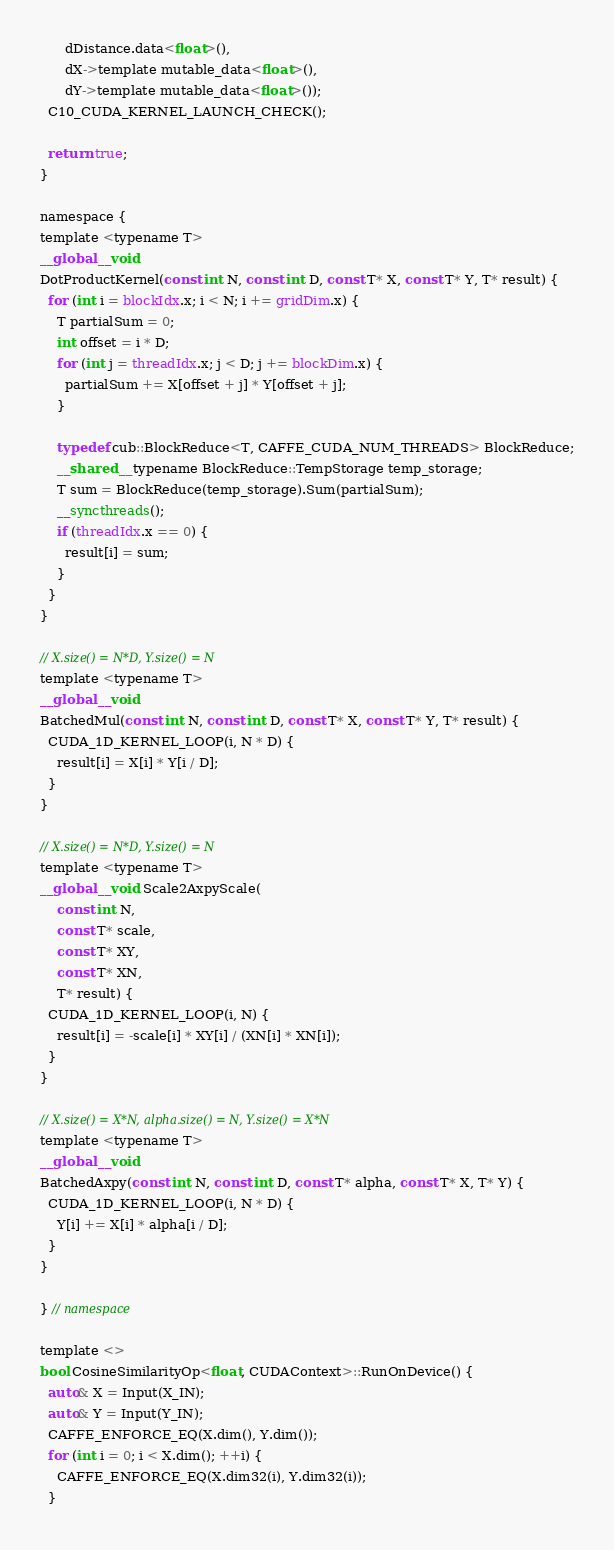<code> <loc_0><loc_0><loc_500><loc_500><_Cuda_>      dDistance.data<float>(),
      dX->template mutable_data<float>(),
      dY->template mutable_data<float>());
  C10_CUDA_KERNEL_LAUNCH_CHECK();

  return true;
}

namespace {
template <typename T>
__global__ void
DotProductKernel(const int N, const int D, const T* X, const T* Y, T* result) {
  for (int i = blockIdx.x; i < N; i += gridDim.x) {
    T partialSum = 0;
    int offset = i * D;
    for (int j = threadIdx.x; j < D; j += blockDim.x) {
      partialSum += X[offset + j] * Y[offset + j];
    }

    typedef cub::BlockReduce<T, CAFFE_CUDA_NUM_THREADS> BlockReduce;
    __shared__ typename BlockReduce::TempStorage temp_storage;
    T sum = BlockReduce(temp_storage).Sum(partialSum);
    __syncthreads();
    if (threadIdx.x == 0) {
      result[i] = sum;
    }
  }
}

// X.size() = N*D, Y.size() = N
template <typename T>
__global__ void
BatchedMul(const int N, const int D, const T* X, const T* Y, T* result) {
  CUDA_1D_KERNEL_LOOP(i, N * D) {
    result[i] = X[i] * Y[i / D];
  }
}

// X.size() = N*D, Y.size() = N
template <typename T>
__global__ void Scale2AxpyScale(
    const int N,
    const T* scale,
    const T* XY,
    const T* XN,
    T* result) {
  CUDA_1D_KERNEL_LOOP(i, N) {
    result[i] = -scale[i] * XY[i] / (XN[i] * XN[i]);
  }
}

// X.size() = X*N, alpha.size() = N, Y.size() = X*N
template <typename T>
__global__ void
BatchedAxpy(const int N, const int D, const T* alpha, const T* X, T* Y) {
  CUDA_1D_KERNEL_LOOP(i, N * D) {
    Y[i] += X[i] * alpha[i / D];
  }
}

} // namespace

template <>
bool CosineSimilarityOp<float, CUDAContext>::RunOnDevice() {
  auto& X = Input(X_IN);
  auto& Y = Input(Y_IN);
  CAFFE_ENFORCE_EQ(X.dim(), Y.dim());
  for (int i = 0; i < X.dim(); ++i) {
    CAFFE_ENFORCE_EQ(X.dim32(i), Y.dim32(i));
  }</code> 